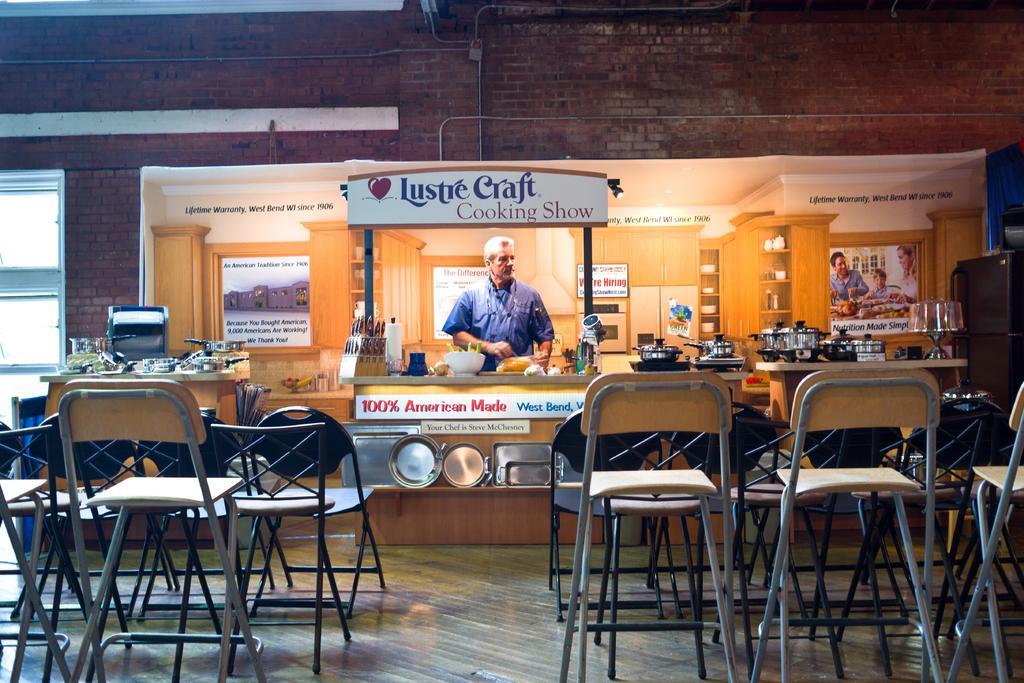In one or two sentences, can you explain what this image depicts? In the foreground I can see chairs, kitchen cabinet on which I can see vessels, kitchen tools and stoves. In the background I can see a board, person is standing, window and three persons. At the top I can see a wall off bricks. This image is taken may be during night. 